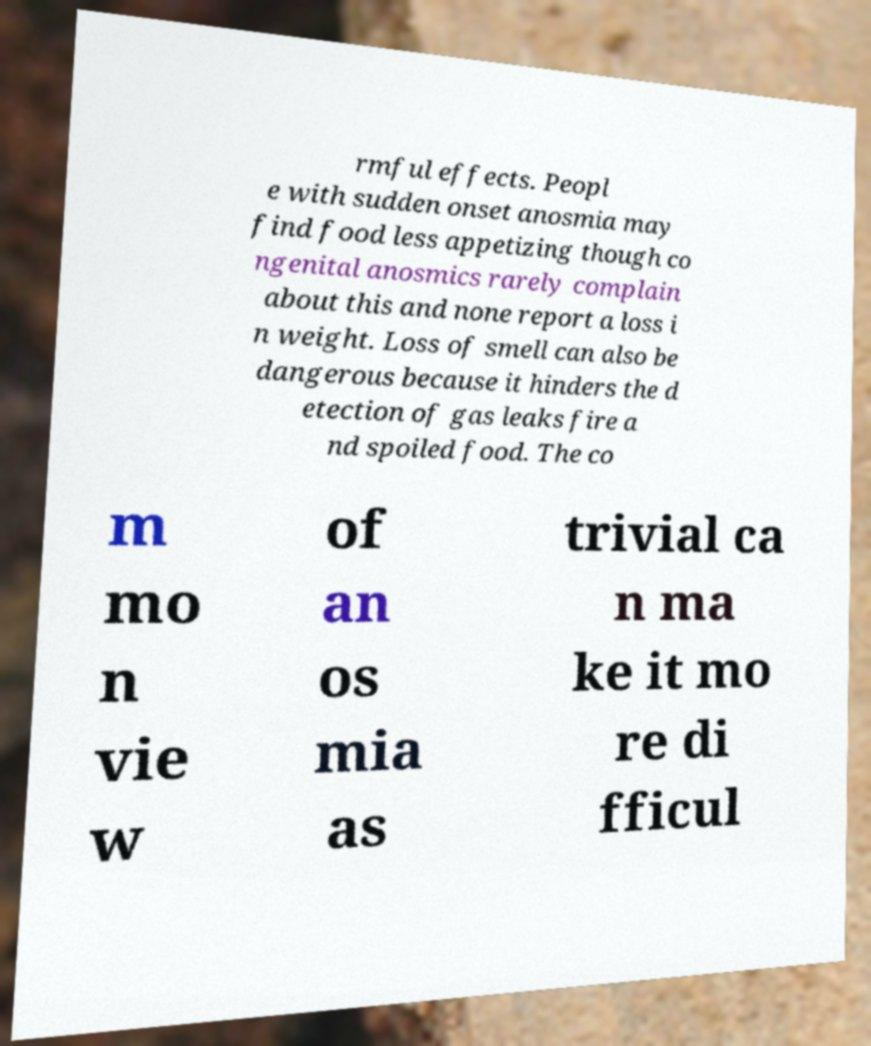What messages or text are displayed in this image? I need them in a readable, typed format. rmful effects. Peopl e with sudden onset anosmia may find food less appetizing though co ngenital anosmics rarely complain about this and none report a loss i n weight. Loss of smell can also be dangerous because it hinders the d etection of gas leaks fire a nd spoiled food. The co m mo n vie w of an os mia as trivial ca n ma ke it mo re di fficul 